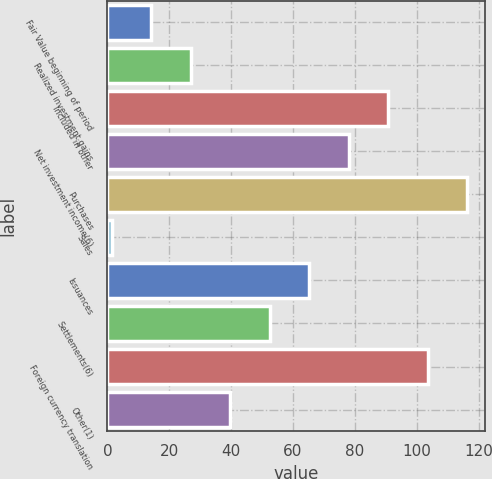Convert chart. <chart><loc_0><loc_0><loc_500><loc_500><bar_chart><fcel>Fair Value beginning of period<fcel>Realized investment gains<fcel>Included in other<fcel>Net investment income(6)<fcel>Purchases<fcel>Sales<fcel>Issuances<fcel>Settlements(6)<fcel>Foreign currency translation<fcel>Other(1)<nl><fcel>14.19<fcel>26.95<fcel>90.75<fcel>77.99<fcel>116.27<fcel>1.43<fcel>65.23<fcel>52.47<fcel>103.51<fcel>39.71<nl></chart> 